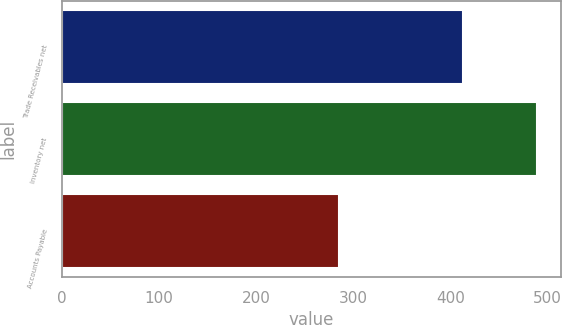<chart> <loc_0><loc_0><loc_500><loc_500><bar_chart><fcel>Trade Receivables net<fcel>Inventory net<fcel>Accounts Payable<nl><fcel>413<fcel>489<fcel>285<nl></chart> 